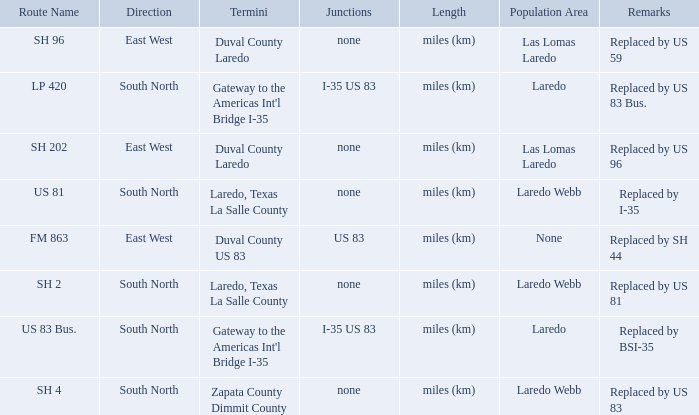Which population areas have "replaced by us 83" listed in their remarks section? Laredo Webb. Would you be able to parse every entry in this table? {'header': ['Route Name', 'Direction', 'Termini', 'Junctions', 'Length', 'Population Area', 'Remarks'], 'rows': [['SH 96', 'East West', 'Duval County Laredo', 'none', 'miles (km)', 'Las Lomas Laredo', 'Replaced by US 59'], ['LP 420', 'South North', "Gateway to the Americas Int'l Bridge I-35", 'I-35 US 83', 'miles (km)', 'Laredo', 'Replaced by US 83 Bus.'], ['SH 202', 'East West', 'Duval County Laredo', 'none', 'miles (km)', 'Las Lomas Laredo', 'Replaced by US 96'], ['US 81', 'South North', 'Laredo, Texas La Salle County', 'none', 'miles (km)', 'Laredo Webb', 'Replaced by I-35'], ['FM 863', 'East West', 'Duval County US 83', 'US 83', 'miles (km)', 'None', 'Replaced by SH 44'], ['SH 2', 'South North', 'Laredo, Texas La Salle County', 'none', 'miles (km)', 'Laredo Webb', 'Replaced by US 81'], ['US 83 Bus.', 'South North', "Gateway to the Americas Int'l Bridge I-35", 'I-35 US 83', 'miles (km)', 'Laredo', 'Replaced by BSI-35'], ['SH 4', 'South North', 'Zapata County Dimmit County', 'none', 'miles (km)', 'Laredo Webb', 'Replaced by US 83']]} 